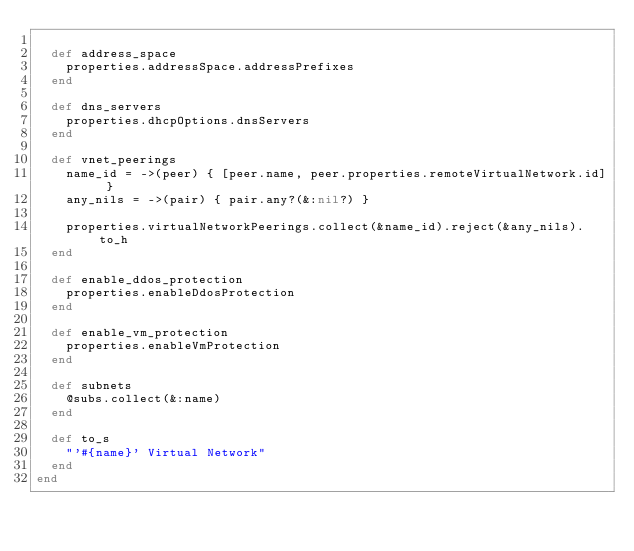Convert code to text. <code><loc_0><loc_0><loc_500><loc_500><_Ruby_>
  def address_space
    properties.addressSpace.addressPrefixes
  end

  def dns_servers
    properties.dhcpOptions.dnsServers
  end

  def vnet_peerings
    name_id = ->(peer) { [peer.name, peer.properties.remoteVirtualNetwork.id] }
    any_nils = ->(pair) { pair.any?(&:nil?) }

    properties.virtualNetworkPeerings.collect(&name_id).reject(&any_nils).to_h
  end

  def enable_ddos_protection
    properties.enableDdosProtection
  end

  def enable_vm_protection
    properties.enableVmProtection
  end

  def subnets
    @subs.collect(&:name)
  end

  def to_s
    "'#{name}' Virtual Network"
  end
end
</code> 